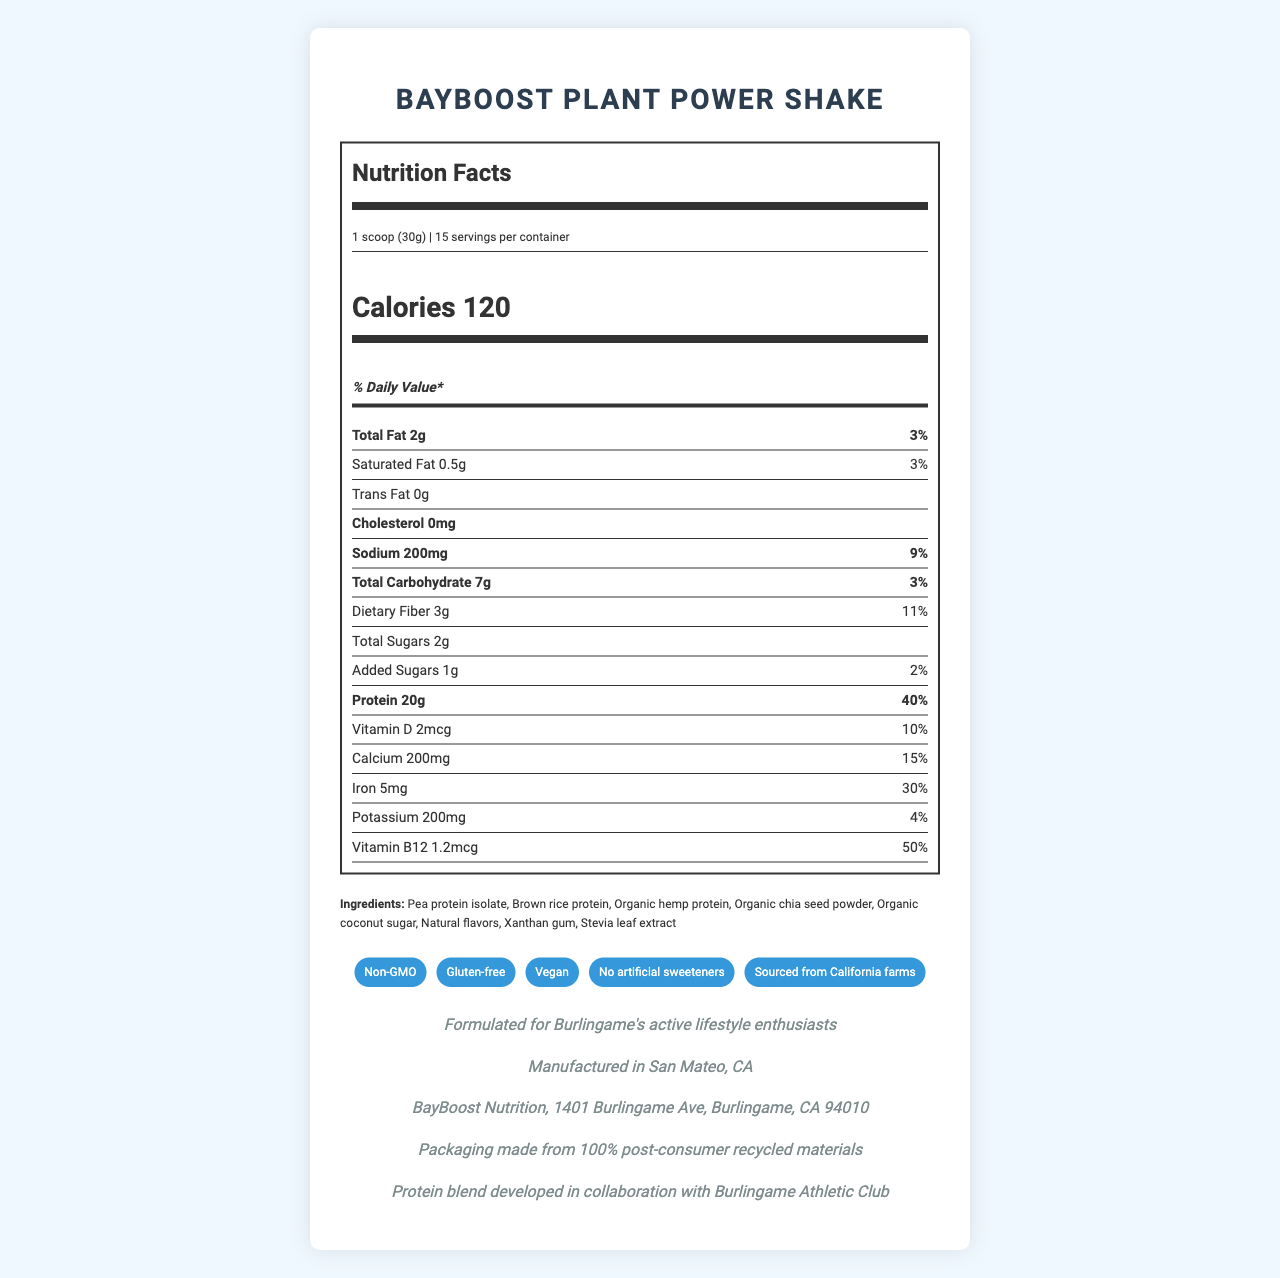what is the serving size for the BayBoost Plant Power Shake? The serving size is specified in the document as "1 scoop (30g)".
Answer: 1 scoop (30g) how many servings per container are there for the BayBoost Plant Power Shake? The document mentions that there are 15 servings per container.
Answer: 15 how many calories are in one serving of BayBoost Plant Power Shake? The document clearly states that there are 120 calories per serving.
Answer: 120 what is the daily value percentage of protein in one serving? The daily value percentage for protein is given as 40% in the document.
Answer: 40% what are the main ingredients in the BayBoost Plant Power Shake? The first few ingredients listed in the document are Pea protein isolate, Brown rice protein, and Organic hemp protein.
Answer: Pea protein isolate, Brown rice protein, Organic hemp protein what is the total fat content per serving? The document indicates that the total fat content per serving is 2g.
Answer: 2g which of the following vitamins is present in the highest daily value percentage in the BayBoost Plant Power Shake? 1. Vitamin D 2. Calcium 3. Iron 4. Vitamin B12 The document shows that Vitamin B12 has a daily value percentage of 50%, the highest among the listed options.
Answer: Vitamin B12 which claim is part of the BayBoost Plant Power Shake's marketing? A. Low calorie B. Non-GMO C. High caffeine D. Sugar-free The document includes the claim “Non-GMO” among its product claims.
Answer: B. Non-GMO is the BayBoost Plant Power Shake gluten-free? The document lists "Gluten-free" as one of its product claims.
Answer: Yes what is the main purpose of the BayBoost Plant Power Shake according to the document? The document mentions that the shake is formulated for Burlingame's active lifestyle enthusiasts.
Answer: Formulated for Burlingame's active lifestyle enthusiasts where is the BayBoost Plant Power Shake manufactured? The manufacturing location is stated as San Mateo, CA in the document.
Answer: San Mateo, CA what kind of packaging does the BayBoost Plant Power Shake use? The document states that the packaging is made from 100% post-consumer recycled materials.
Answer: Packaging made from 100% post-consumer recycled materials does the BayBoost Plant Power Shake contain any artificial sweeteners? The document claims "No artificial sweeteners".
Answer: No what is the total carbohydrate content per serving? The total carbohydrate content per serving is given as 7g in the document.
Answer: 7g what is the total amount of added sugars in the BayBoost Plant Power Shake? The document lists 1g of added sugars.
Answer: 1g is the BayBoost Plant Power Shake suitable for vegans? One of the product claims is "Vegan".
Answer: Yes what is the sodium content in one serving of BayBoost Plant Power Shake? The document specifies that there are 200mg of sodium per serving.
Answer: 200mg can you list any of the claims made about the BayBoost Plant Power Shake's ingredients or sourcing? The document contains these claims under "product claims".
Answer: Non-GMO, Gluten-free, Vegan, No artificial sweeteners, Sourced from California farms summarize the main features of the BayBoost Plant Power Shake. The document provides comprehensive details about the product, including its nutritional content, claims, ingredients, manufacturing location, and community appeal.
Answer: BayBoost Plant Power Shake is a plant-based protein shake designed for Burlingame's fitness community. It offers 20g of protein per serving with a variety of essential nutrients like calcium, iron, and vitamin B12. The shake is non-GMO, gluten-free, vegan, and has no artificial sweeteners. It uses environmentally friendly packaging and is manufactured locally in San Mateo, CA. Ingredients include pea protein isolate, brown rice protein, and organic hemp protein. what is the specific address of BayBoost Nutrition company? The document provides the company's address as 1401 Burlingame Ave, Burlingame, CA 94010.
Answer: 1401 Burlingame Ave, Burlingame, CA 94010 what is the color of the packaging of BayBoost Plant Power Shake? The document does not provide any details about the color of the packaging.
Answer: Not enough information 